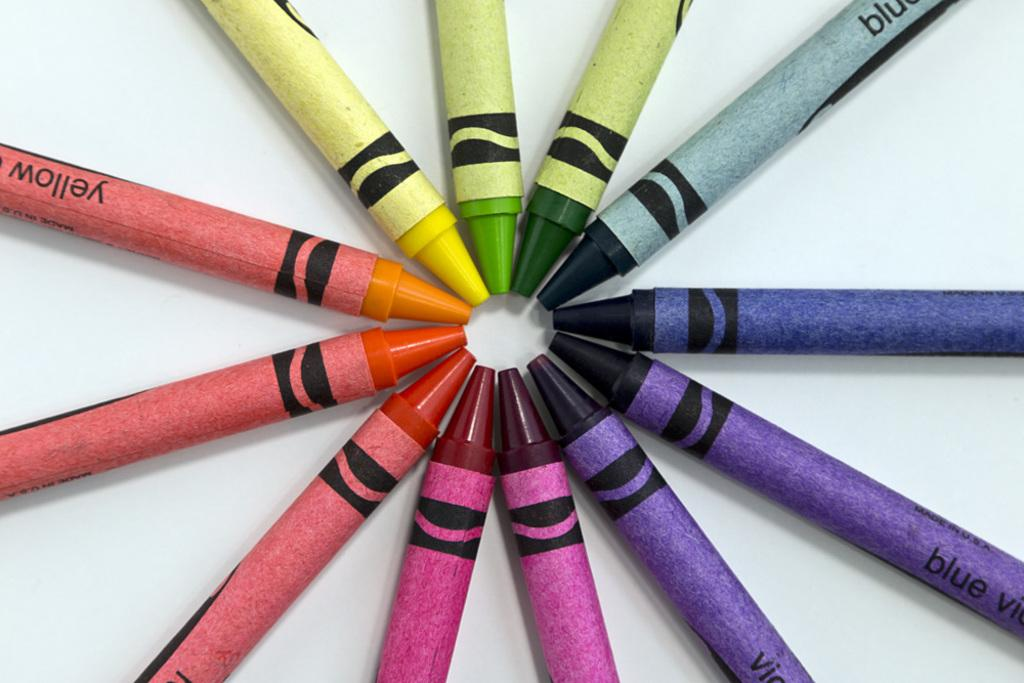<image>
Share a concise interpretation of the image provided. Brightly colored crayons made in the USA arranged like wheel spokes. 